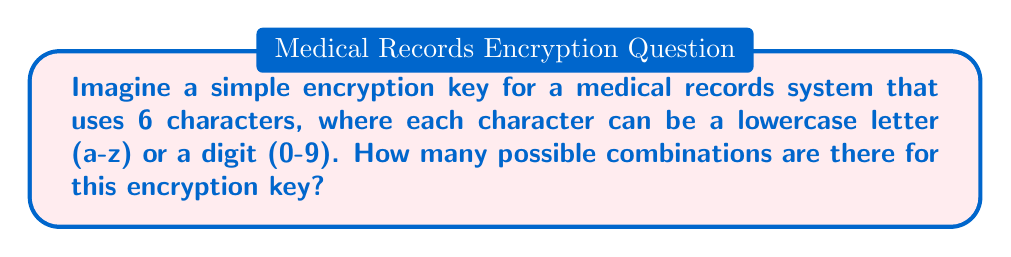Teach me how to tackle this problem. Let's approach this step-by-step:

1) First, we need to determine how many options we have for each character:
   - 26 lowercase letters (a-z)
   - 10 digits (0-9)
   Total options per character: 26 + 10 = 36

2) Now, we need to consider that we have 6 characters in the key, and each character can be any of these 36 options.

3) This scenario follows the multiplication principle of counting. For each position, we have 36 choices, and this is true for all 6 positions.

4) Therefore, the total number of possible combinations is:

   $$ 36 \times 36 \times 36 \times 36 \times 36 \times 36 = 36^6 $$

5) We can calculate this:

   $$ 36^6 = 2,176,782,336 $$

This large number of possibilities helps ensure the security of the medical records, providing comfort that patient information is well-protected.
Answer: $36^6 = 2,176,782,336$ 